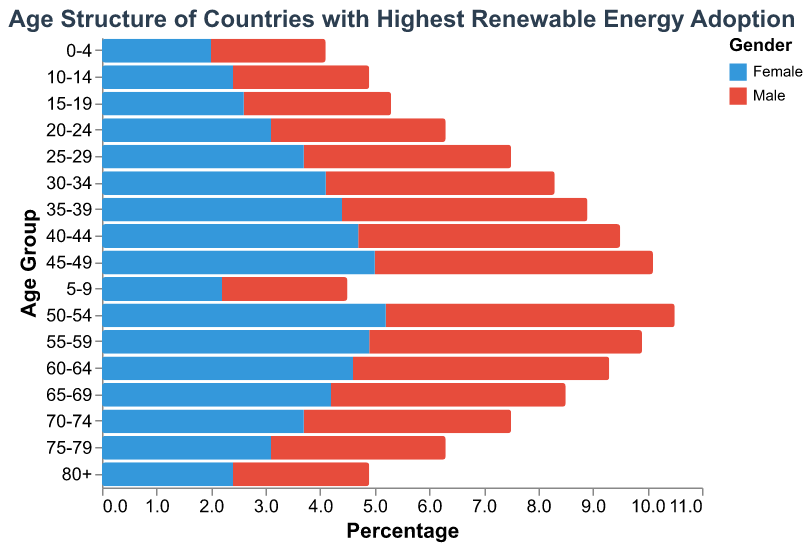What is the title of the figure? The title of the figure can be found at the top, usually centered. In this case, it is displayed in the "title" section specified in the figure description.
Answer: Age Structure of Countries with Highest Renewable Energy Adoption What is the percentage of males in the 25-29 age group? To find this, look at the data point for the age group "25-29" under the "Male" category. The value is shown as -3.8%, indicating the percentage of males.
Answer: 3.8% Which age group has the highest percentage of females? Compare the data values under the "Female" category for each age group. The highest value is 5.2% for the age group "50-54".
Answer: 50-54 What’s the difference in the percentage of males and females in the 55-59 age group? The data shows 5.0% for males and 4.9% for females in the 55-59 age group. Subtract the percentage for females from the percentage for males (5.0 - 4.9 = 0.1).
Answer: 0.1% Is there any age group where the percentage of females is higher than the percentage of males? By looking at the data, we observe that in almost all age groups, the percentage of males is slightly higher or equal to females. There is no age group where females surpass males.
Answer: No Which age group has the smallest percentage of the population? Find the smallest values for both males and females. For males, the smallest value is 2.1% in the age group "0-4", and for females, it is 2.0%, also in the "0-4" age group. Combine these to determine the smallest overall.
Answer: 0-4 What trend can we observe about the percentage of males and females as age increases from 0-4 to 80+? Initially, the percentages gradually increase with age and peak around the 50-54 age group for both males and females. From there, the percentages start to decline consistently as age increases beyond 54 years.
Answer: Increases, peaks, then declines Compare the percentage of males in the 40-44 age group with the percentage of females in the same group. Which is higher and by how much? For the 40-44 age group, the percentage for males is 4.8% and for females is 4.7%. Subtract the female percentage from the male percentage (4.8 - 4.7 = 0.1).
Answer: Males by 0.1% How does the percentage of males and females in the 60-64 age group compare? Both the male and female percentages in the 60-64 age group are close but not equal. The percentage for males is 4.7%, and the percentage for females is 4.6%.
Answer: Males are slightly higher What could be a reasonable societal implication of the observed population structure in terms of energy consumption? A higher percentage of middle-aged and older adults implies a stable or growing need for consistent energy consumption patterns, while the higher younger population may drive future energy consumption growth.
Answer: Consistent with potential growth 